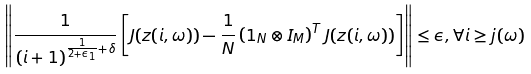<formula> <loc_0><loc_0><loc_500><loc_500>\left \| \frac { 1 } { ( i + 1 ) ^ { \frac { 1 } { 2 + \epsilon _ { 1 } } + \delta } } \left [ J ( z ( i , \omega ) ) - \frac { 1 } { N } \left ( 1 _ { N } \otimes I _ { M } \right ) ^ { T } J ( z ( i , \omega ) ) \right ] \right \| \leq \epsilon , \forall i \geq j ( \omega )</formula> 